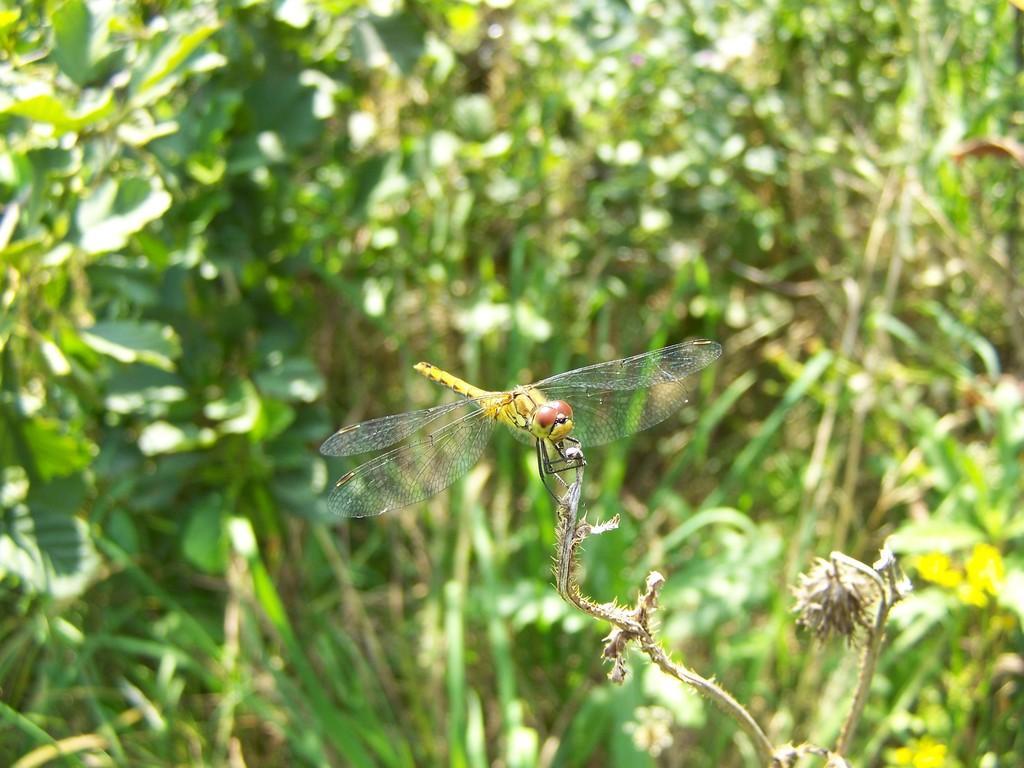In one or two sentences, can you explain what this image depicts? In this picture I can see a dragonfly on the brown color thing. I see that it is blurred in the background and I can see number of plants. 